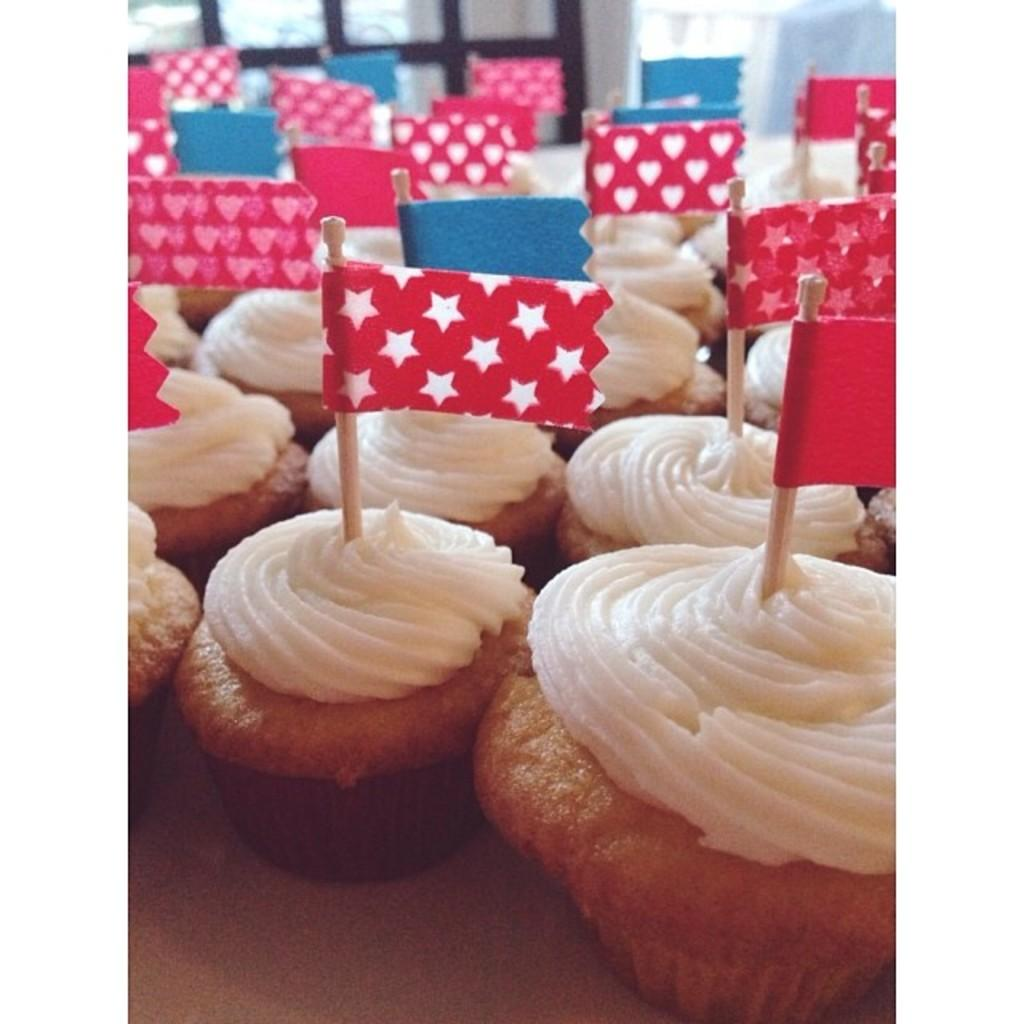What type of food can be seen in the image? There are muffins in the image. What else is present in the image besides the muffins? There are color papers on small sticks in the image. What type of iron can be seen in the image? There is no iron present in the image. Is there any popcorn visible in the image? There is no popcorn present in the image. 